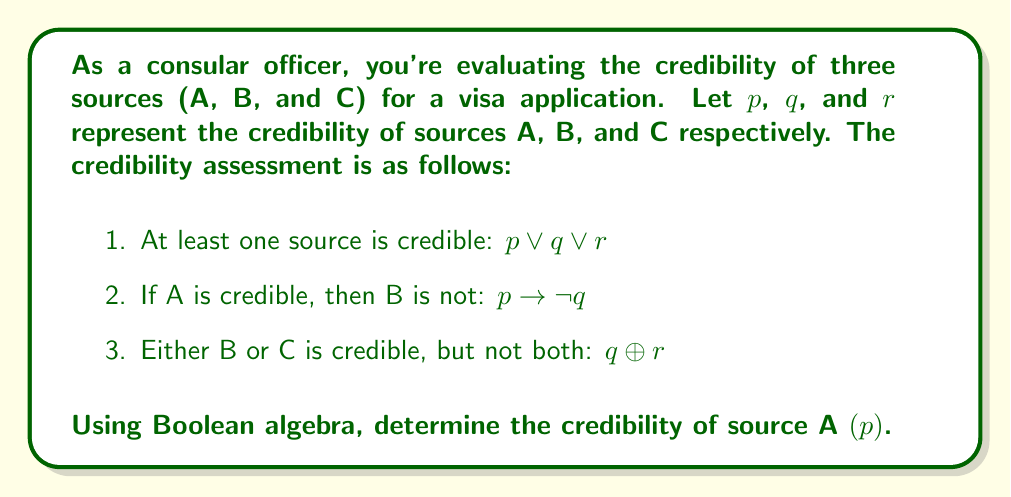Help me with this question. Let's approach this step-by-step using Boolean algebra:

1) From condition 2: $p \rightarrow \neg q$ is equivalent to $\neg p \lor \neg q$

2) From condition 3: $q \oplus r$ is equivalent to $(q \lor r) \land (\neg q \lor \neg r)$

3) Combining conditions 1 and 3:
   $(p \lor q \lor r) \land (q \lor r) \land (\neg q \lor \neg r)$
   
   Simplify: $(p \lor q \lor r) \land (\neg q \lor \neg r)$

4) Now, let's combine this with condition 2:
   $(p \lor q \lor r) \land (\neg q \lor \neg r) \land (\neg p \lor \neg q)$

5) Distribute $\neg q$:
   $(p \lor q \lor r) \land (\neg q) \land (\neg p \lor \neg q)$

6) Simplify:
   $(p \lor r) \land \neg q \land \neg p$

7) Further simplify:
   $r \land \neg q \land \neg p$

Therefore, the only solution that satisfies all conditions is when $p$ is false, $q$ is false, and $r$ is true.
Answer: $p = \text{False}$ 